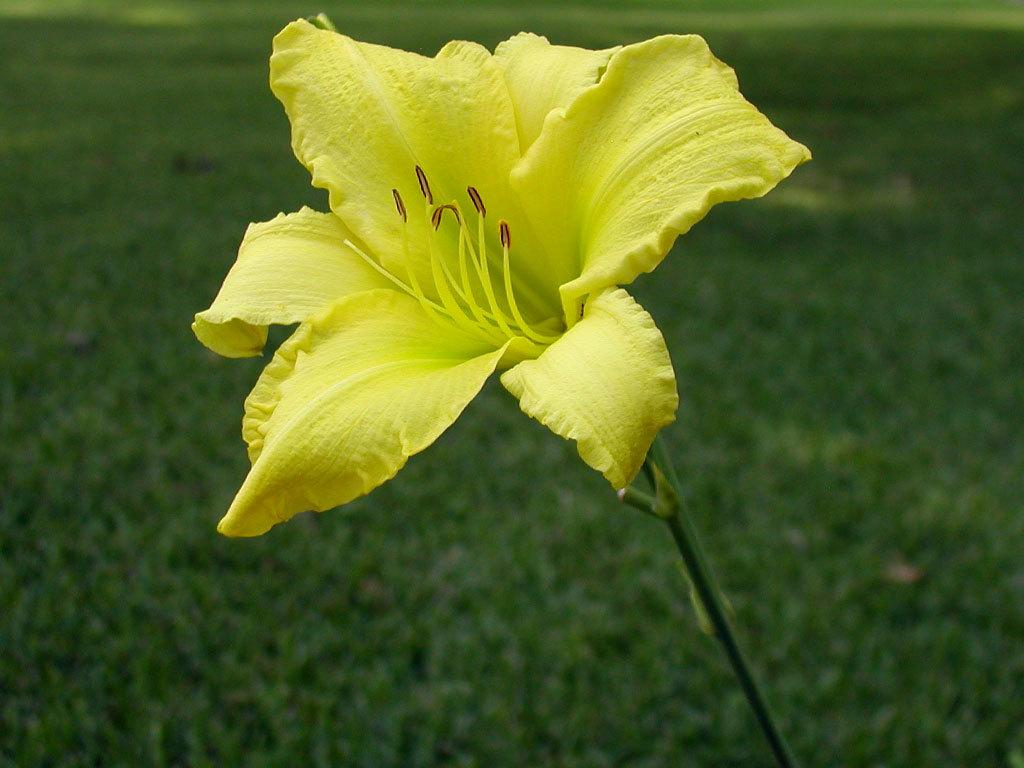What is the main subject of the image? There is a flower in the image. What part of the flower is visible in the image? There is a stem in the image. What can be seen in the background of the image? There is greenery in the background of the image. How many legs can be seen on the flower in the image? Flowers do not have legs, so there are no legs visible on the flower in the image. 